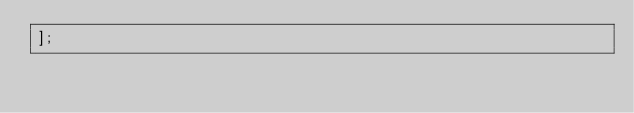Convert code to text. <code><loc_0><loc_0><loc_500><loc_500><_JavaScript_>];
</code> 